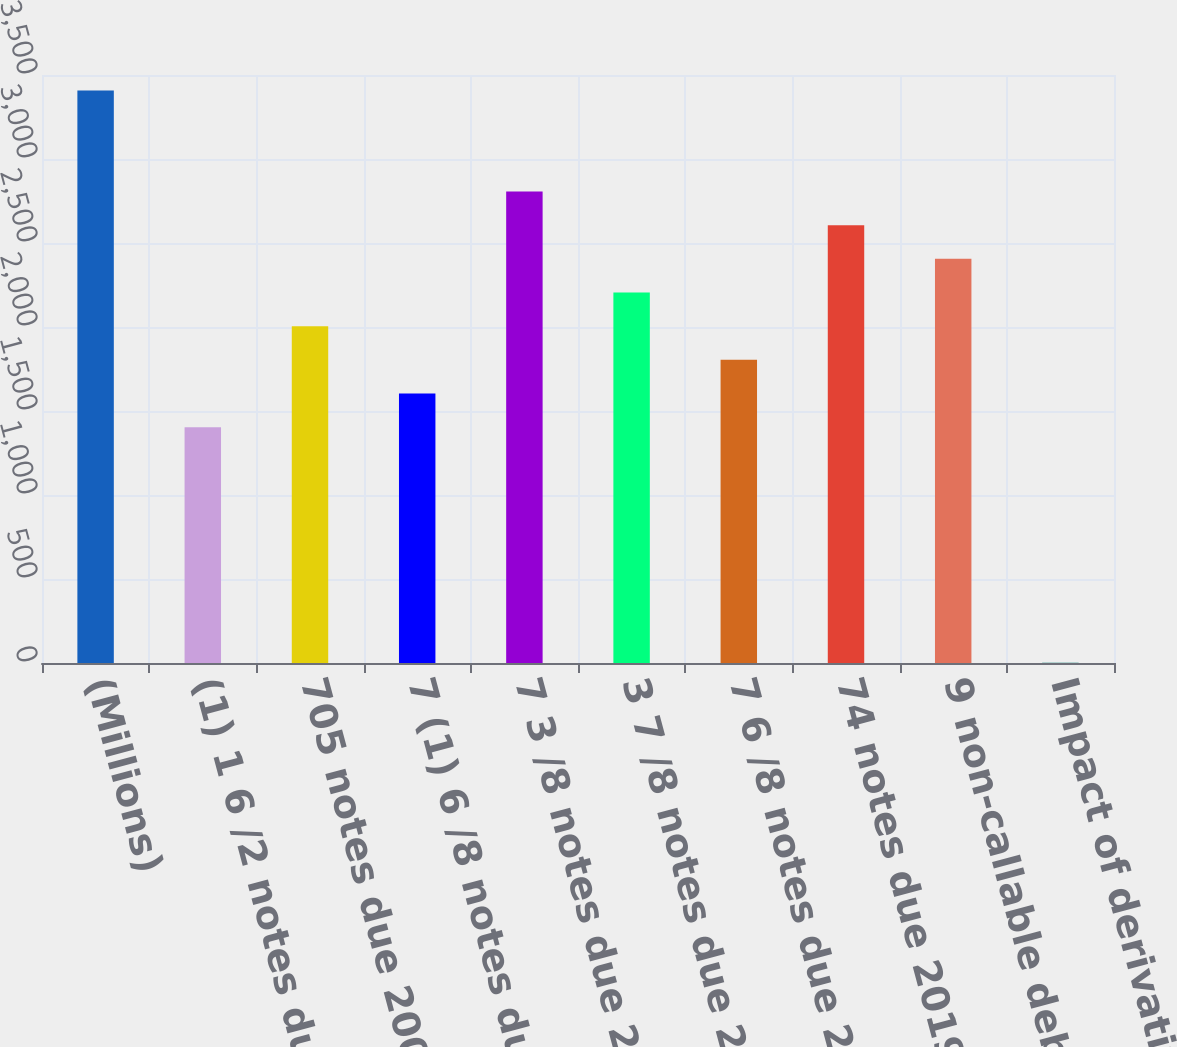Convert chart to OTSL. <chart><loc_0><loc_0><loc_500><loc_500><bar_chart><fcel>(Millions)<fcel>(1) 1 6 /2 notes due 2007<fcel>705 notes due 2009 (1)<fcel>7 (1) 6 /8 notes due 2012<fcel>7 3 /8 notes due 2015 ( 300)<fcel>3 7 /8 notes due 2016<fcel>7 6 /8 notes due 2017<fcel>74 notes due 2019<fcel>9 non-callable debentures due<fcel>Impact of derivatives on debt<nl><fcel>3407.8<fcel>1403.8<fcel>2005<fcel>1604.2<fcel>2806.6<fcel>2205.4<fcel>1804.6<fcel>2606.2<fcel>2405.8<fcel>1<nl></chart> 